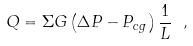Convert formula to latex. <formula><loc_0><loc_0><loc_500><loc_500>Q = \Sigma G \left ( \Delta P - P _ { c g } \right ) \frac { 1 } { L } \ ,</formula> 